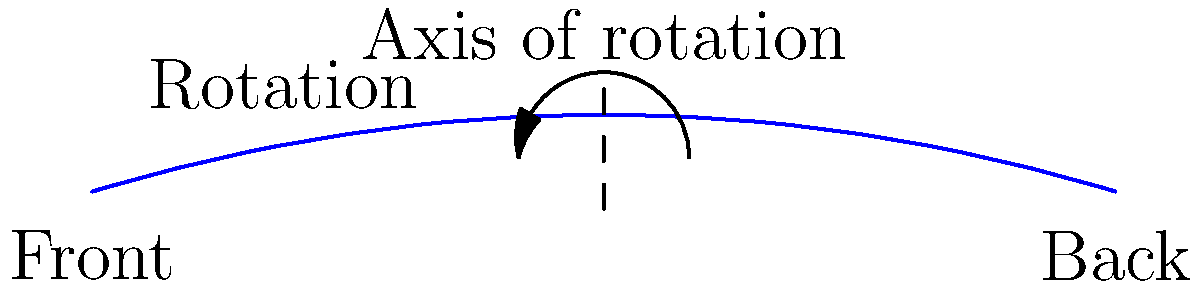In naval architecture, a ship's hull design is often rotated around a central axis to create a 3D model. If the blueprint shown represents half of the ship's cross-section and is rotated $360°$ around the central axis, what type of 3D shape would be generated, and how does this relate to the ship's design process? To understand this transformation and its relevance to ship design, let's break it down step by step:

1. The blueprint shown represents half of the ship's cross-section, essentially a 2D curve.

2. The dashed line in the middle represents the axis of rotation, which is the centerline of the ship.

3. When this 2D curve is rotated $360°$ (a full revolution) around the central axis, it creates a 3D shape.

4. The resulting 3D shape would be a solid of revolution. In this case, it would be similar to an elongated ellipsoid, but with a more complex, ship-like profile.

5. This shape is called a "solid of revolution" because it's created by revolving a 2D shape around an axis.

6. In naval architecture, this process is crucial because:
   a) It allows designers to visualize the full 3D hull shape from a 2D drawing.
   b) It helps in calculating important properties like displacement and stability.
   c) It forms the basis for more detailed 3D modeling and analysis of the ship's hydrodynamics.

7. Historically, this method was used to create physical models. Today, it's often done using computer-aided design (CAD) software, but the principle remains the same.

8. This technique is an application of rotational symmetry, which is common in ship design as most ships are symmetrical along their length.

The resulting 3D shape accurately represents the volume and form of the ship's hull, which is critical for understanding how the ship will perform in water.
Answer: Solid of revolution (representing the ship's hull) 